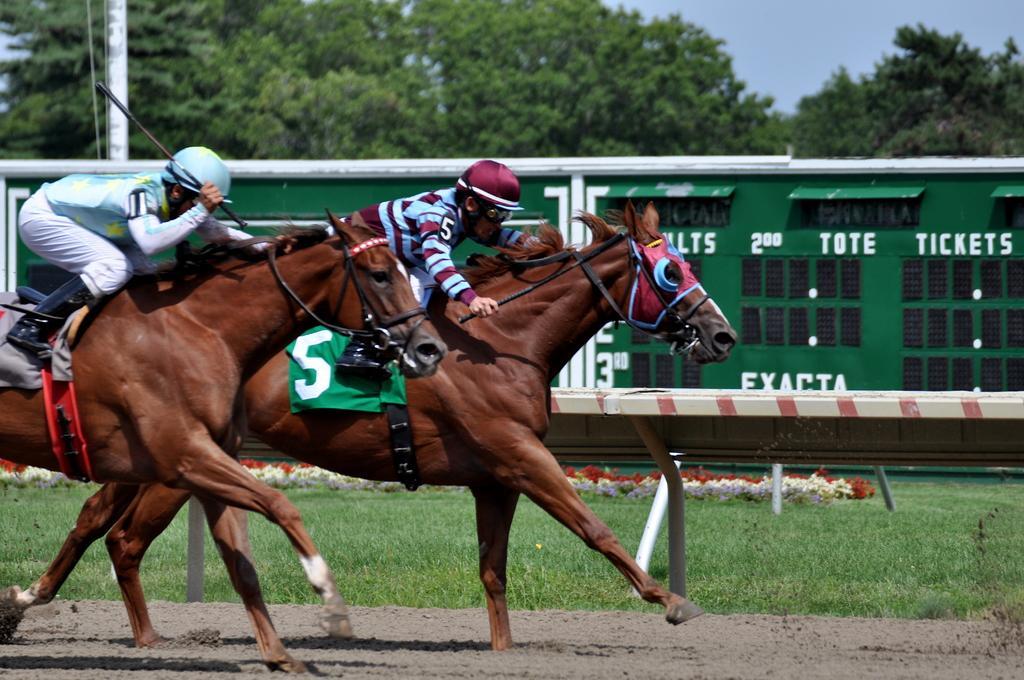In one or two sentences, can you explain what this image depicts? In this picture there are two person sitting on the house. Here we can see fencing. At the back we can see green color wooden hut. In the background we can see many trees. At the top right there is a sky. Here we can see grass. On the top left corner there is a pole. 